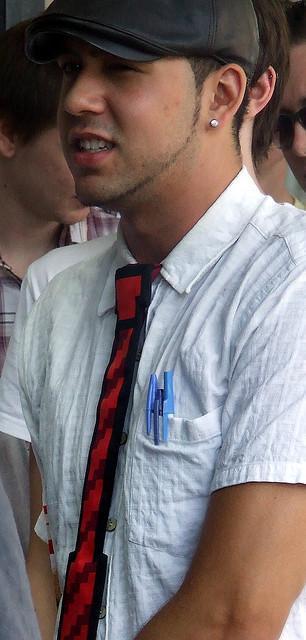What company is known for making the objects in the man's pocket?
Choose the correct response, then elucidate: 'Answer: answer
Rationale: rationale.'
Options: Bic, dell, ibm, chipotle. Answer: bic.
Rationale: There are pens, not food items or computers, in the man's pocket. 